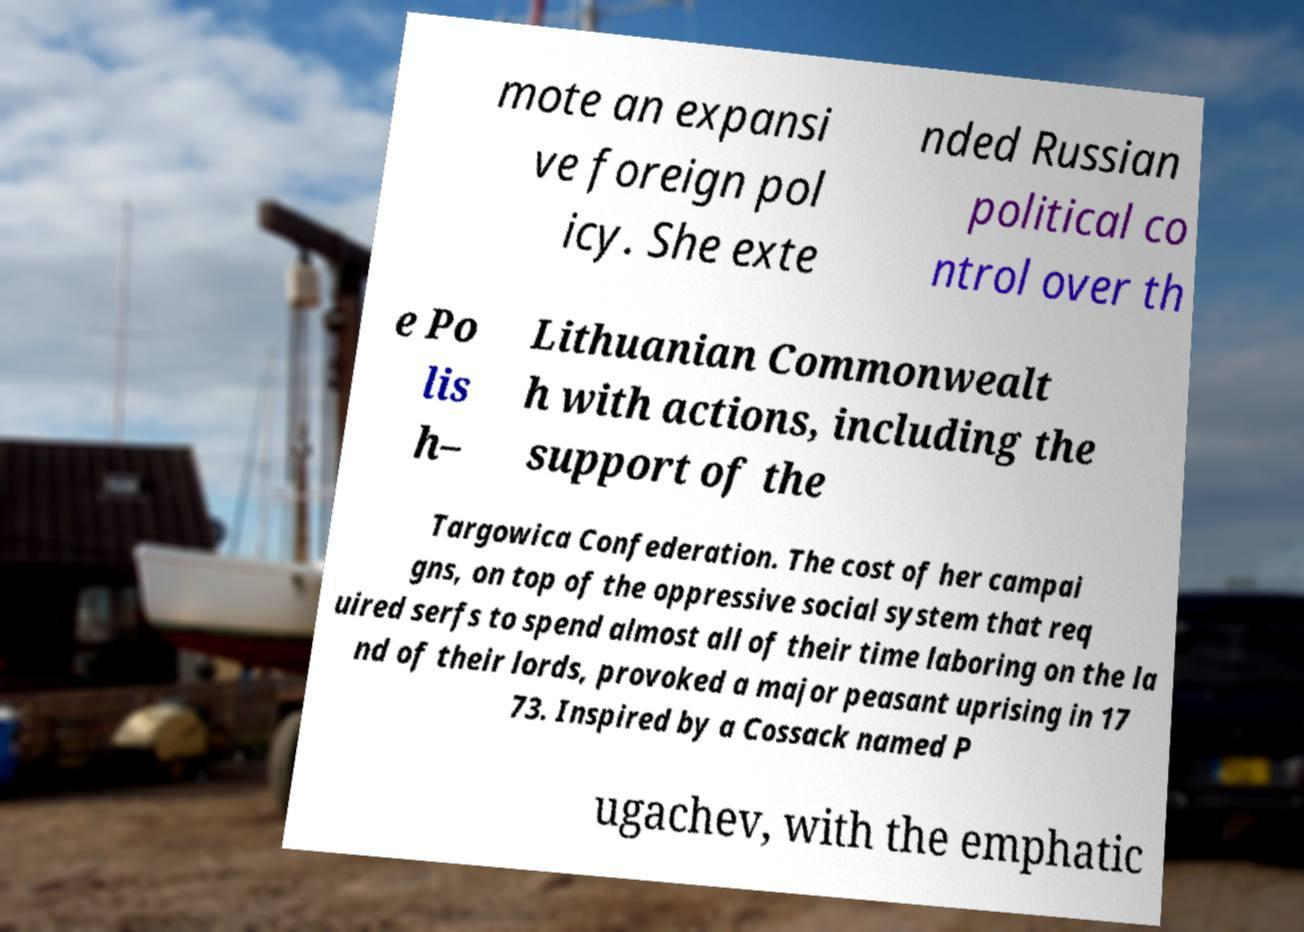Can you accurately transcribe the text from the provided image for me? mote an expansi ve foreign pol icy. She exte nded Russian political co ntrol over th e Po lis h– Lithuanian Commonwealt h with actions, including the support of the Targowica Confederation. The cost of her campai gns, on top of the oppressive social system that req uired serfs to spend almost all of their time laboring on the la nd of their lords, provoked a major peasant uprising in 17 73. Inspired by a Cossack named P ugachev, with the emphatic 